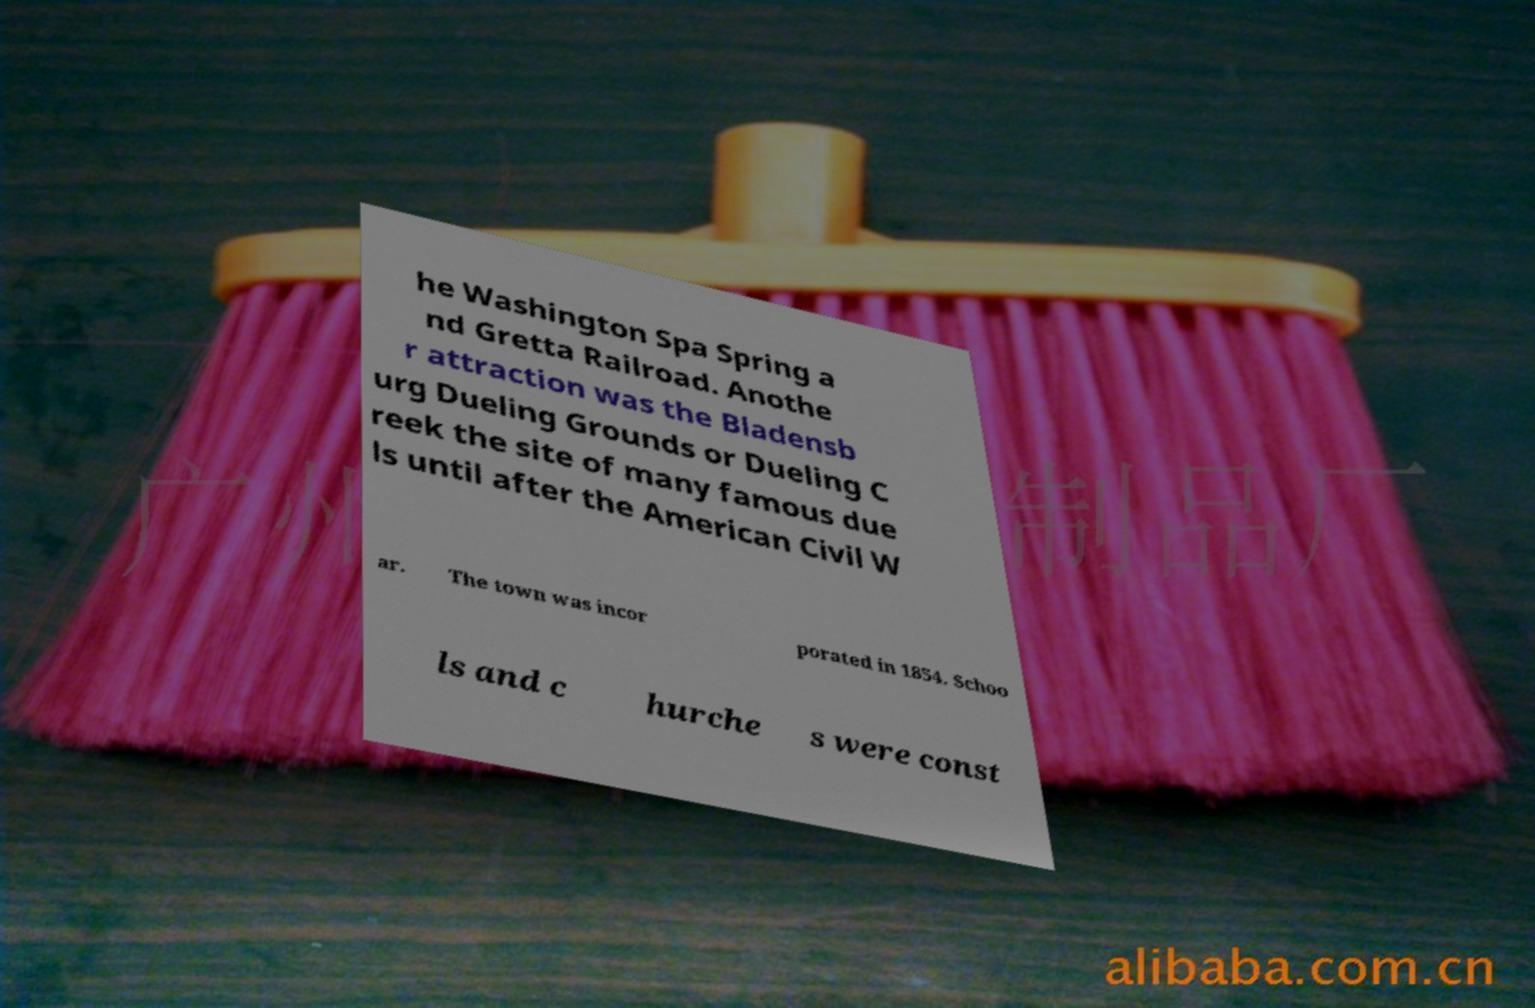For documentation purposes, I need the text within this image transcribed. Could you provide that? he Washington Spa Spring a nd Gretta Railroad. Anothe r attraction was the Bladensb urg Dueling Grounds or Dueling C reek the site of many famous due ls until after the American Civil W ar. The town was incor porated in 1854. Schoo ls and c hurche s were const 